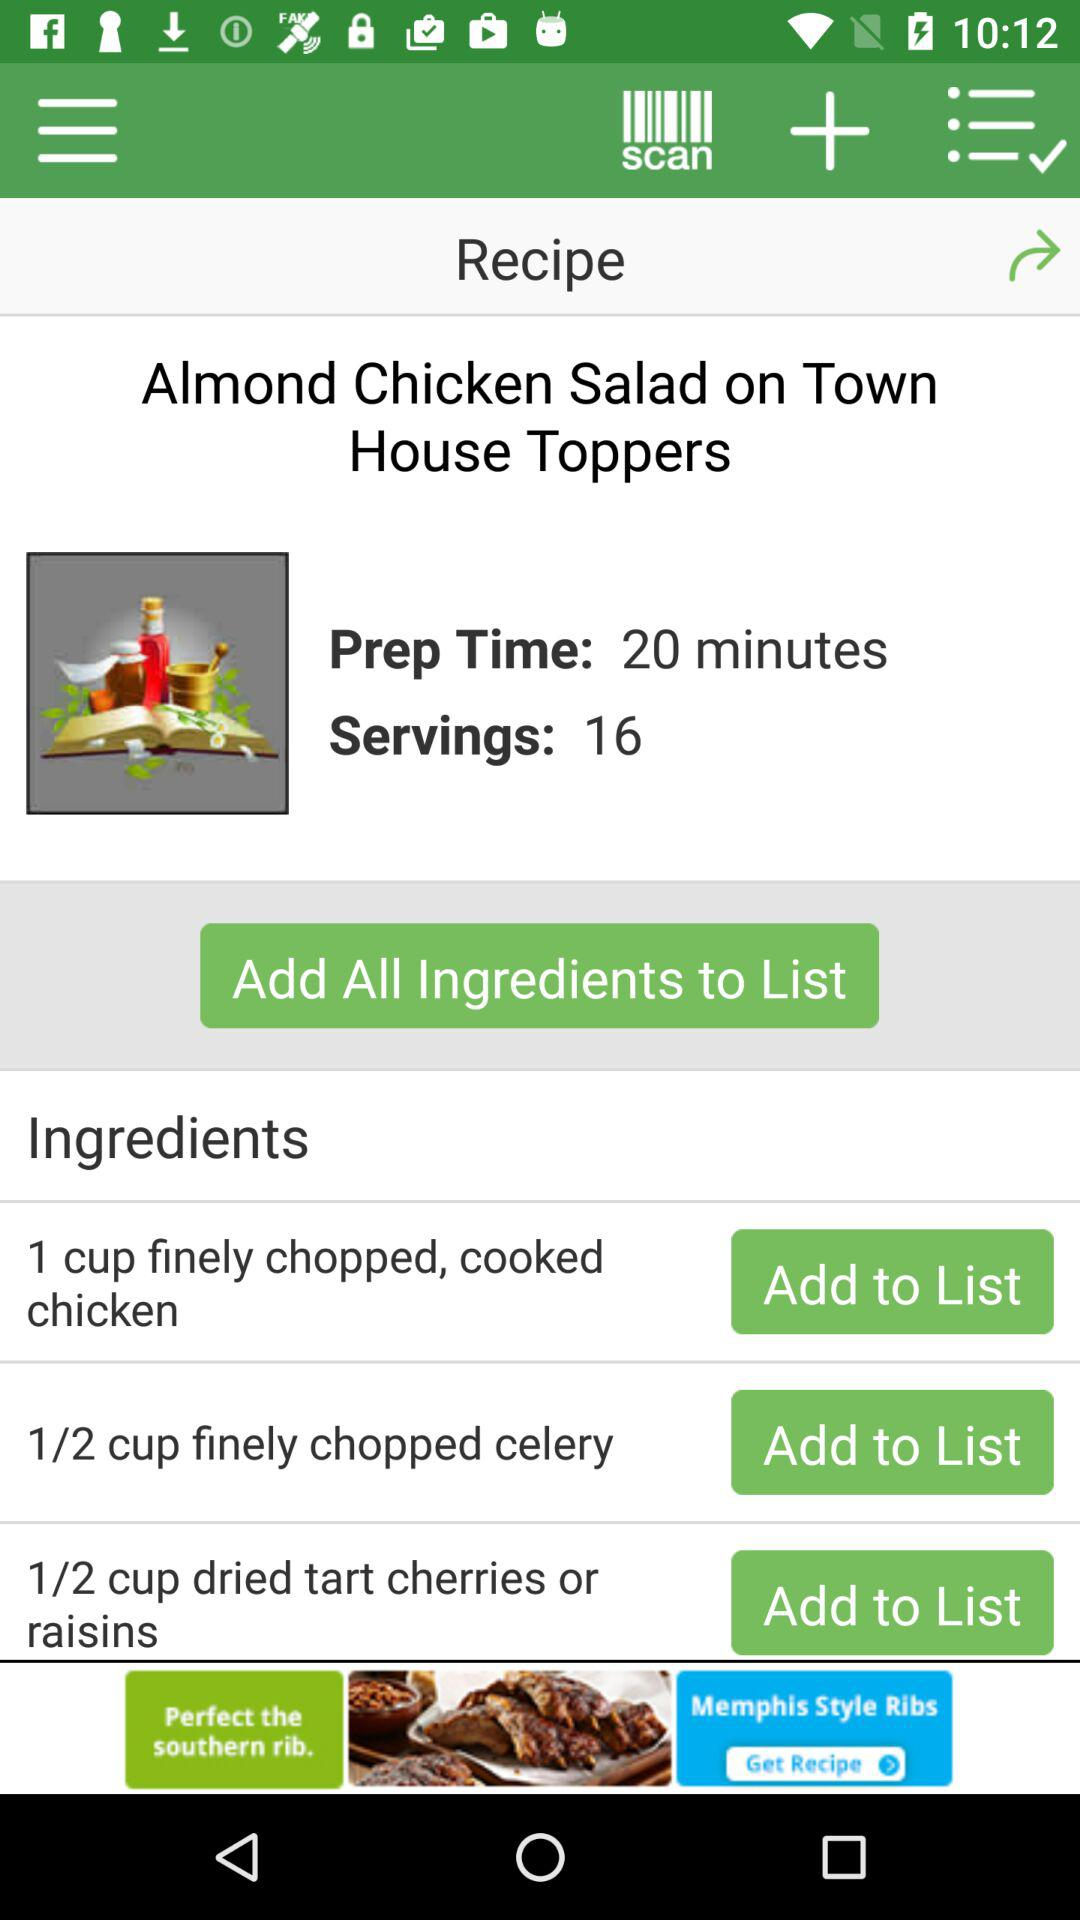How many servings of "Almond Chicken Salad" are there? There are 16 servings of "Almond Chicken Salad". 